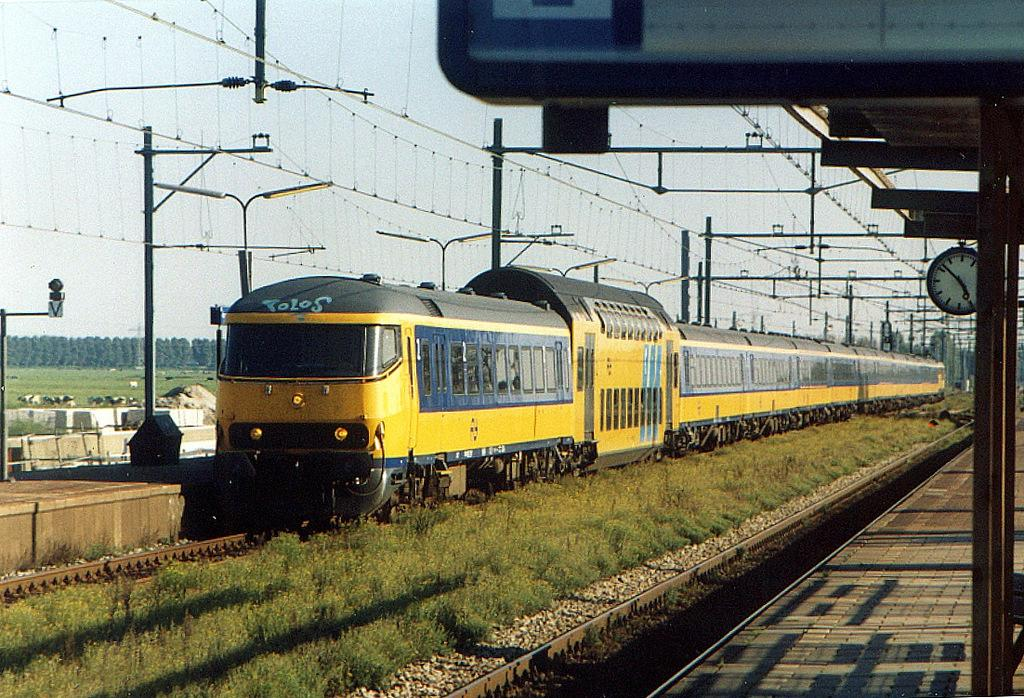<image>
Create a compact narrative representing the image presented. A yellow train at the train station with a clock that says it is 4:52. 